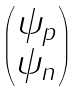<formula> <loc_0><loc_0><loc_500><loc_500>\begin{pmatrix} \psi _ { p } \\ \psi _ { n } \end{pmatrix}</formula> 